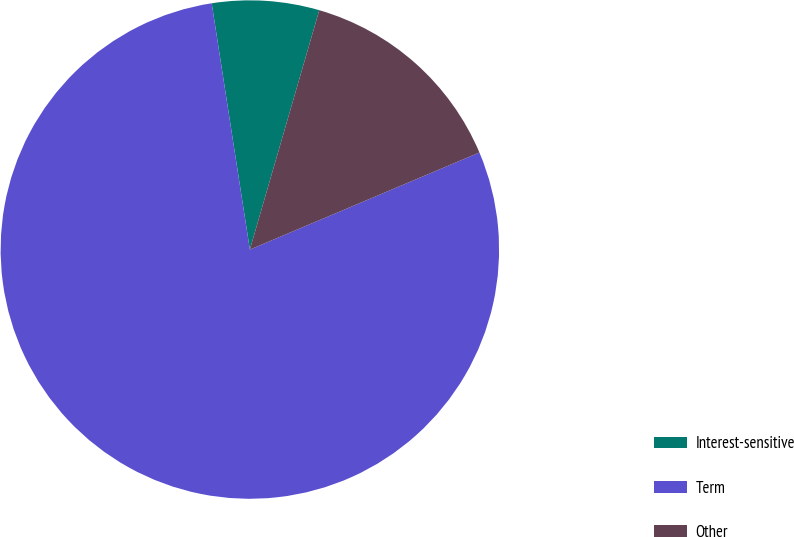<chart> <loc_0><loc_0><loc_500><loc_500><pie_chart><fcel>Interest-sensitive<fcel>Term<fcel>Other<nl><fcel>6.94%<fcel>78.92%<fcel>14.14%<nl></chart> 